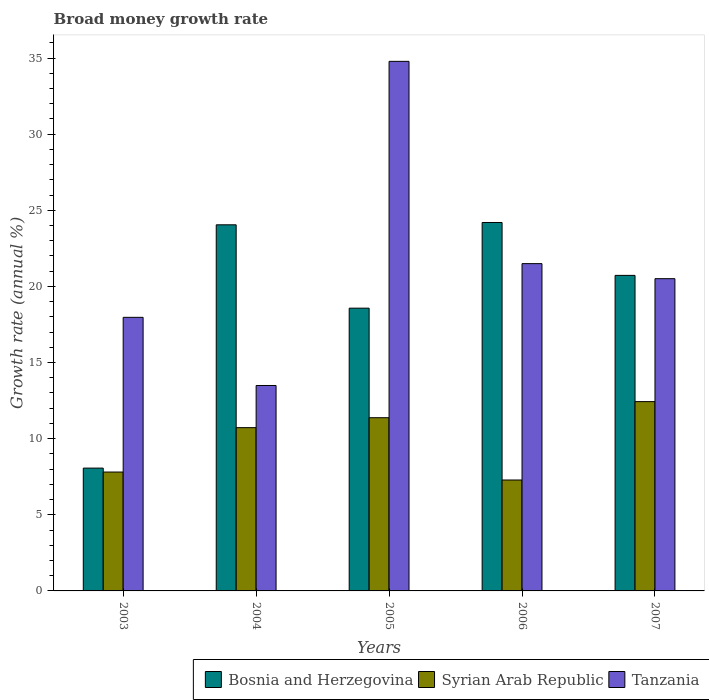How many different coloured bars are there?
Your answer should be compact. 3. How many groups of bars are there?
Your answer should be compact. 5. Are the number of bars per tick equal to the number of legend labels?
Provide a succinct answer. Yes. Are the number of bars on each tick of the X-axis equal?
Provide a short and direct response. Yes. How many bars are there on the 1st tick from the left?
Your answer should be compact. 3. How many bars are there on the 2nd tick from the right?
Your answer should be compact. 3. In how many cases, is the number of bars for a given year not equal to the number of legend labels?
Provide a succinct answer. 0. What is the growth rate in Bosnia and Herzegovina in 2007?
Make the answer very short. 20.72. Across all years, what is the maximum growth rate in Tanzania?
Your response must be concise. 34.78. Across all years, what is the minimum growth rate in Syrian Arab Republic?
Your answer should be compact. 7.29. In which year was the growth rate in Tanzania maximum?
Offer a very short reply. 2005. In which year was the growth rate in Syrian Arab Republic minimum?
Ensure brevity in your answer.  2006. What is the total growth rate in Bosnia and Herzegovina in the graph?
Your answer should be compact. 95.61. What is the difference between the growth rate in Bosnia and Herzegovina in 2003 and that in 2006?
Make the answer very short. -16.13. What is the difference between the growth rate in Syrian Arab Republic in 2005 and the growth rate in Bosnia and Herzegovina in 2004?
Ensure brevity in your answer.  -12.67. What is the average growth rate in Bosnia and Herzegovina per year?
Your answer should be very brief. 19.12. In the year 2006, what is the difference between the growth rate in Bosnia and Herzegovina and growth rate in Syrian Arab Republic?
Keep it short and to the point. 16.91. In how many years, is the growth rate in Tanzania greater than 20 %?
Make the answer very short. 3. What is the ratio of the growth rate in Syrian Arab Republic in 2004 to that in 2005?
Offer a terse response. 0.94. Is the growth rate in Bosnia and Herzegovina in 2003 less than that in 2004?
Keep it short and to the point. Yes. Is the difference between the growth rate in Bosnia and Herzegovina in 2005 and 2006 greater than the difference between the growth rate in Syrian Arab Republic in 2005 and 2006?
Ensure brevity in your answer.  No. What is the difference between the highest and the second highest growth rate in Syrian Arab Republic?
Keep it short and to the point. 1.06. What is the difference between the highest and the lowest growth rate in Tanzania?
Keep it short and to the point. 21.29. Is the sum of the growth rate in Bosnia and Herzegovina in 2005 and 2007 greater than the maximum growth rate in Tanzania across all years?
Offer a very short reply. Yes. What does the 3rd bar from the left in 2007 represents?
Your answer should be very brief. Tanzania. What does the 2nd bar from the right in 2004 represents?
Give a very brief answer. Syrian Arab Republic. Is it the case that in every year, the sum of the growth rate in Tanzania and growth rate in Syrian Arab Republic is greater than the growth rate in Bosnia and Herzegovina?
Provide a short and direct response. Yes. Are all the bars in the graph horizontal?
Your answer should be compact. No. What is the difference between two consecutive major ticks on the Y-axis?
Offer a terse response. 5. Does the graph contain any zero values?
Your answer should be very brief. No. Where does the legend appear in the graph?
Offer a terse response. Bottom right. What is the title of the graph?
Make the answer very short. Broad money growth rate. What is the label or title of the X-axis?
Your answer should be very brief. Years. What is the label or title of the Y-axis?
Provide a short and direct response. Growth rate (annual %). What is the Growth rate (annual %) in Bosnia and Herzegovina in 2003?
Your answer should be very brief. 8.07. What is the Growth rate (annual %) in Syrian Arab Republic in 2003?
Your answer should be compact. 7.81. What is the Growth rate (annual %) in Tanzania in 2003?
Your answer should be very brief. 17.97. What is the Growth rate (annual %) in Bosnia and Herzegovina in 2004?
Your answer should be compact. 24.05. What is the Growth rate (annual %) of Syrian Arab Republic in 2004?
Offer a terse response. 10.72. What is the Growth rate (annual %) of Tanzania in 2004?
Your answer should be very brief. 13.49. What is the Growth rate (annual %) of Bosnia and Herzegovina in 2005?
Offer a very short reply. 18.57. What is the Growth rate (annual %) of Syrian Arab Republic in 2005?
Your response must be concise. 11.38. What is the Growth rate (annual %) in Tanzania in 2005?
Provide a succinct answer. 34.78. What is the Growth rate (annual %) of Bosnia and Herzegovina in 2006?
Make the answer very short. 24.2. What is the Growth rate (annual %) in Syrian Arab Republic in 2006?
Ensure brevity in your answer.  7.29. What is the Growth rate (annual %) of Tanzania in 2006?
Your response must be concise. 21.5. What is the Growth rate (annual %) in Bosnia and Herzegovina in 2007?
Keep it short and to the point. 20.72. What is the Growth rate (annual %) in Syrian Arab Republic in 2007?
Your answer should be very brief. 12.43. What is the Growth rate (annual %) of Tanzania in 2007?
Offer a very short reply. 20.51. Across all years, what is the maximum Growth rate (annual %) in Bosnia and Herzegovina?
Offer a terse response. 24.2. Across all years, what is the maximum Growth rate (annual %) of Syrian Arab Republic?
Keep it short and to the point. 12.43. Across all years, what is the maximum Growth rate (annual %) in Tanzania?
Offer a very short reply. 34.78. Across all years, what is the minimum Growth rate (annual %) of Bosnia and Herzegovina?
Offer a terse response. 8.07. Across all years, what is the minimum Growth rate (annual %) in Syrian Arab Republic?
Your answer should be very brief. 7.29. Across all years, what is the minimum Growth rate (annual %) of Tanzania?
Offer a very short reply. 13.49. What is the total Growth rate (annual %) of Bosnia and Herzegovina in the graph?
Provide a short and direct response. 95.61. What is the total Growth rate (annual %) of Syrian Arab Republic in the graph?
Give a very brief answer. 49.63. What is the total Growth rate (annual %) of Tanzania in the graph?
Offer a very short reply. 108.25. What is the difference between the Growth rate (annual %) in Bosnia and Herzegovina in 2003 and that in 2004?
Your answer should be compact. -15.98. What is the difference between the Growth rate (annual %) in Syrian Arab Republic in 2003 and that in 2004?
Offer a terse response. -2.91. What is the difference between the Growth rate (annual %) in Tanzania in 2003 and that in 2004?
Provide a short and direct response. 4.48. What is the difference between the Growth rate (annual %) in Bosnia and Herzegovina in 2003 and that in 2005?
Your answer should be compact. -10.5. What is the difference between the Growth rate (annual %) of Syrian Arab Republic in 2003 and that in 2005?
Make the answer very short. -3.57. What is the difference between the Growth rate (annual %) of Tanzania in 2003 and that in 2005?
Your answer should be compact. -16.81. What is the difference between the Growth rate (annual %) of Bosnia and Herzegovina in 2003 and that in 2006?
Ensure brevity in your answer.  -16.13. What is the difference between the Growth rate (annual %) of Syrian Arab Republic in 2003 and that in 2006?
Your answer should be compact. 0.52. What is the difference between the Growth rate (annual %) of Tanzania in 2003 and that in 2006?
Make the answer very short. -3.53. What is the difference between the Growth rate (annual %) in Bosnia and Herzegovina in 2003 and that in 2007?
Offer a terse response. -12.66. What is the difference between the Growth rate (annual %) in Syrian Arab Republic in 2003 and that in 2007?
Your answer should be very brief. -4.62. What is the difference between the Growth rate (annual %) of Tanzania in 2003 and that in 2007?
Your answer should be very brief. -2.54. What is the difference between the Growth rate (annual %) in Bosnia and Herzegovina in 2004 and that in 2005?
Offer a very short reply. 5.48. What is the difference between the Growth rate (annual %) in Syrian Arab Republic in 2004 and that in 2005?
Your answer should be very brief. -0.65. What is the difference between the Growth rate (annual %) of Tanzania in 2004 and that in 2005?
Provide a short and direct response. -21.29. What is the difference between the Growth rate (annual %) in Bosnia and Herzegovina in 2004 and that in 2006?
Keep it short and to the point. -0.15. What is the difference between the Growth rate (annual %) in Syrian Arab Republic in 2004 and that in 2006?
Your answer should be very brief. 3.44. What is the difference between the Growth rate (annual %) of Tanzania in 2004 and that in 2006?
Offer a very short reply. -8. What is the difference between the Growth rate (annual %) in Bosnia and Herzegovina in 2004 and that in 2007?
Provide a succinct answer. 3.32. What is the difference between the Growth rate (annual %) in Syrian Arab Republic in 2004 and that in 2007?
Keep it short and to the point. -1.71. What is the difference between the Growth rate (annual %) of Tanzania in 2004 and that in 2007?
Provide a succinct answer. -7.02. What is the difference between the Growth rate (annual %) of Bosnia and Herzegovina in 2005 and that in 2006?
Provide a short and direct response. -5.63. What is the difference between the Growth rate (annual %) of Syrian Arab Republic in 2005 and that in 2006?
Make the answer very short. 4.09. What is the difference between the Growth rate (annual %) in Tanzania in 2005 and that in 2006?
Offer a terse response. 13.29. What is the difference between the Growth rate (annual %) of Bosnia and Herzegovina in 2005 and that in 2007?
Your answer should be compact. -2.15. What is the difference between the Growth rate (annual %) in Syrian Arab Republic in 2005 and that in 2007?
Ensure brevity in your answer.  -1.06. What is the difference between the Growth rate (annual %) of Tanzania in 2005 and that in 2007?
Offer a very short reply. 14.27. What is the difference between the Growth rate (annual %) in Bosnia and Herzegovina in 2006 and that in 2007?
Ensure brevity in your answer.  3.47. What is the difference between the Growth rate (annual %) in Syrian Arab Republic in 2006 and that in 2007?
Offer a very short reply. -5.15. What is the difference between the Growth rate (annual %) of Bosnia and Herzegovina in 2003 and the Growth rate (annual %) of Syrian Arab Republic in 2004?
Keep it short and to the point. -2.66. What is the difference between the Growth rate (annual %) of Bosnia and Herzegovina in 2003 and the Growth rate (annual %) of Tanzania in 2004?
Offer a terse response. -5.43. What is the difference between the Growth rate (annual %) of Syrian Arab Republic in 2003 and the Growth rate (annual %) of Tanzania in 2004?
Your response must be concise. -5.68. What is the difference between the Growth rate (annual %) of Bosnia and Herzegovina in 2003 and the Growth rate (annual %) of Syrian Arab Republic in 2005?
Provide a succinct answer. -3.31. What is the difference between the Growth rate (annual %) of Bosnia and Herzegovina in 2003 and the Growth rate (annual %) of Tanzania in 2005?
Offer a very short reply. -26.72. What is the difference between the Growth rate (annual %) in Syrian Arab Republic in 2003 and the Growth rate (annual %) in Tanzania in 2005?
Offer a very short reply. -26.97. What is the difference between the Growth rate (annual %) of Bosnia and Herzegovina in 2003 and the Growth rate (annual %) of Syrian Arab Republic in 2006?
Keep it short and to the point. 0.78. What is the difference between the Growth rate (annual %) in Bosnia and Herzegovina in 2003 and the Growth rate (annual %) in Tanzania in 2006?
Offer a very short reply. -13.43. What is the difference between the Growth rate (annual %) in Syrian Arab Republic in 2003 and the Growth rate (annual %) in Tanzania in 2006?
Provide a short and direct response. -13.69. What is the difference between the Growth rate (annual %) of Bosnia and Herzegovina in 2003 and the Growth rate (annual %) of Syrian Arab Republic in 2007?
Make the answer very short. -4.37. What is the difference between the Growth rate (annual %) of Bosnia and Herzegovina in 2003 and the Growth rate (annual %) of Tanzania in 2007?
Give a very brief answer. -12.44. What is the difference between the Growth rate (annual %) of Syrian Arab Republic in 2003 and the Growth rate (annual %) of Tanzania in 2007?
Make the answer very short. -12.7. What is the difference between the Growth rate (annual %) in Bosnia and Herzegovina in 2004 and the Growth rate (annual %) in Syrian Arab Republic in 2005?
Provide a short and direct response. 12.67. What is the difference between the Growth rate (annual %) of Bosnia and Herzegovina in 2004 and the Growth rate (annual %) of Tanzania in 2005?
Provide a succinct answer. -10.74. What is the difference between the Growth rate (annual %) of Syrian Arab Republic in 2004 and the Growth rate (annual %) of Tanzania in 2005?
Offer a terse response. -24.06. What is the difference between the Growth rate (annual %) in Bosnia and Herzegovina in 2004 and the Growth rate (annual %) in Syrian Arab Republic in 2006?
Keep it short and to the point. 16.76. What is the difference between the Growth rate (annual %) in Bosnia and Herzegovina in 2004 and the Growth rate (annual %) in Tanzania in 2006?
Your answer should be compact. 2.55. What is the difference between the Growth rate (annual %) in Syrian Arab Republic in 2004 and the Growth rate (annual %) in Tanzania in 2006?
Offer a very short reply. -10.77. What is the difference between the Growth rate (annual %) of Bosnia and Herzegovina in 2004 and the Growth rate (annual %) of Syrian Arab Republic in 2007?
Your answer should be compact. 11.61. What is the difference between the Growth rate (annual %) in Bosnia and Herzegovina in 2004 and the Growth rate (annual %) in Tanzania in 2007?
Your answer should be very brief. 3.54. What is the difference between the Growth rate (annual %) in Syrian Arab Republic in 2004 and the Growth rate (annual %) in Tanzania in 2007?
Your answer should be very brief. -9.78. What is the difference between the Growth rate (annual %) in Bosnia and Herzegovina in 2005 and the Growth rate (annual %) in Syrian Arab Republic in 2006?
Keep it short and to the point. 11.29. What is the difference between the Growth rate (annual %) in Bosnia and Herzegovina in 2005 and the Growth rate (annual %) in Tanzania in 2006?
Offer a very short reply. -2.92. What is the difference between the Growth rate (annual %) of Syrian Arab Republic in 2005 and the Growth rate (annual %) of Tanzania in 2006?
Provide a succinct answer. -10.12. What is the difference between the Growth rate (annual %) of Bosnia and Herzegovina in 2005 and the Growth rate (annual %) of Syrian Arab Republic in 2007?
Your response must be concise. 6.14. What is the difference between the Growth rate (annual %) in Bosnia and Herzegovina in 2005 and the Growth rate (annual %) in Tanzania in 2007?
Your answer should be very brief. -1.94. What is the difference between the Growth rate (annual %) in Syrian Arab Republic in 2005 and the Growth rate (annual %) in Tanzania in 2007?
Offer a terse response. -9.13. What is the difference between the Growth rate (annual %) of Bosnia and Herzegovina in 2006 and the Growth rate (annual %) of Syrian Arab Republic in 2007?
Offer a very short reply. 11.76. What is the difference between the Growth rate (annual %) of Bosnia and Herzegovina in 2006 and the Growth rate (annual %) of Tanzania in 2007?
Provide a succinct answer. 3.69. What is the difference between the Growth rate (annual %) of Syrian Arab Republic in 2006 and the Growth rate (annual %) of Tanzania in 2007?
Offer a very short reply. -13.22. What is the average Growth rate (annual %) of Bosnia and Herzegovina per year?
Make the answer very short. 19.12. What is the average Growth rate (annual %) of Syrian Arab Republic per year?
Offer a very short reply. 9.93. What is the average Growth rate (annual %) in Tanzania per year?
Your answer should be very brief. 21.65. In the year 2003, what is the difference between the Growth rate (annual %) of Bosnia and Herzegovina and Growth rate (annual %) of Syrian Arab Republic?
Give a very brief answer. 0.26. In the year 2003, what is the difference between the Growth rate (annual %) in Bosnia and Herzegovina and Growth rate (annual %) in Tanzania?
Give a very brief answer. -9.9. In the year 2003, what is the difference between the Growth rate (annual %) in Syrian Arab Republic and Growth rate (annual %) in Tanzania?
Make the answer very short. -10.16. In the year 2004, what is the difference between the Growth rate (annual %) in Bosnia and Herzegovina and Growth rate (annual %) in Syrian Arab Republic?
Your response must be concise. 13.32. In the year 2004, what is the difference between the Growth rate (annual %) in Bosnia and Herzegovina and Growth rate (annual %) in Tanzania?
Offer a very short reply. 10.55. In the year 2004, what is the difference between the Growth rate (annual %) of Syrian Arab Republic and Growth rate (annual %) of Tanzania?
Offer a terse response. -2.77. In the year 2005, what is the difference between the Growth rate (annual %) of Bosnia and Herzegovina and Growth rate (annual %) of Syrian Arab Republic?
Make the answer very short. 7.19. In the year 2005, what is the difference between the Growth rate (annual %) of Bosnia and Herzegovina and Growth rate (annual %) of Tanzania?
Make the answer very short. -16.21. In the year 2005, what is the difference between the Growth rate (annual %) of Syrian Arab Republic and Growth rate (annual %) of Tanzania?
Your answer should be very brief. -23.41. In the year 2006, what is the difference between the Growth rate (annual %) in Bosnia and Herzegovina and Growth rate (annual %) in Syrian Arab Republic?
Provide a short and direct response. 16.91. In the year 2006, what is the difference between the Growth rate (annual %) of Bosnia and Herzegovina and Growth rate (annual %) of Tanzania?
Provide a short and direct response. 2.7. In the year 2006, what is the difference between the Growth rate (annual %) in Syrian Arab Republic and Growth rate (annual %) in Tanzania?
Provide a succinct answer. -14.21. In the year 2007, what is the difference between the Growth rate (annual %) in Bosnia and Herzegovina and Growth rate (annual %) in Syrian Arab Republic?
Your response must be concise. 8.29. In the year 2007, what is the difference between the Growth rate (annual %) in Bosnia and Herzegovina and Growth rate (annual %) in Tanzania?
Your answer should be compact. 0.22. In the year 2007, what is the difference between the Growth rate (annual %) of Syrian Arab Republic and Growth rate (annual %) of Tanzania?
Offer a very short reply. -8.07. What is the ratio of the Growth rate (annual %) of Bosnia and Herzegovina in 2003 to that in 2004?
Your response must be concise. 0.34. What is the ratio of the Growth rate (annual %) of Syrian Arab Republic in 2003 to that in 2004?
Your answer should be compact. 0.73. What is the ratio of the Growth rate (annual %) of Tanzania in 2003 to that in 2004?
Keep it short and to the point. 1.33. What is the ratio of the Growth rate (annual %) in Bosnia and Herzegovina in 2003 to that in 2005?
Ensure brevity in your answer.  0.43. What is the ratio of the Growth rate (annual %) of Syrian Arab Republic in 2003 to that in 2005?
Ensure brevity in your answer.  0.69. What is the ratio of the Growth rate (annual %) of Tanzania in 2003 to that in 2005?
Provide a short and direct response. 0.52. What is the ratio of the Growth rate (annual %) in Bosnia and Herzegovina in 2003 to that in 2006?
Offer a terse response. 0.33. What is the ratio of the Growth rate (annual %) in Syrian Arab Republic in 2003 to that in 2006?
Your answer should be compact. 1.07. What is the ratio of the Growth rate (annual %) in Tanzania in 2003 to that in 2006?
Give a very brief answer. 0.84. What is the ratio of the Growth rate (annual %) of Bosnia and Herzegovina in 2003 to that in 2007?
Your answer should be compact. 0.39. What is the ratio of the Growth rate (annual %) of Syrian Arab Republic in 2003 to that in 2007?
Ensure brevity in your answer.  0.63. What is the ratio of the Growth rate (annual %) in Tanzania in 2003 to that in 2007?
Make the answer very short. 0.88. What is the ratio of the Growth rate (annual %) in Bosnia and Herzegovina in 2004 to that in 2005?
Make the answer very short. 1.29. What is the ratio of the Growth rate (annual %) in Syrian Arab Republic in 2004 to that in 2005?
Keep it short and to the point. 0.94. What is the ratio of the Growth rate (annual %) in Tanzania in 2004 to that in 2005?
Offer a terse response. 0.39. What is the ratio of the Growth rate (annual %) of Bosnia and Herzegovina in 2004 to that in 2006?
Make the answer very short. 0.99. What is the ratio of the Growth rate (annual %) in Syrian Arab Republic in 2004 to that in 2006?
Ensure brevity in your answer.  1.47. What is the ratio of the Growth rate (annual %) in Tanzania in 2004 to that in 2006?
Your answer should be very brief. 0.63. What is the ratio of the Growth rate (annual %) of Bosnia and Herzegovina in 2004 to that in 2007?
Give a very brief answer. 1.16. What is the ratio of the Growth rate (annual %) in Syrian Arab Republic in 2004 to that in 2007?
Offer a very short reply. 0.86. What is the ratio of the Growth rate (annual %) in Tanzania in 2004 to that in 2007?
Your answer should be very brief. 0.66. What is the ratio of the Growth rate (annual %) in Bosnia and Herzegovina in 2005 to that in 2006?
Offer a terse response. 0.77. What is the ratio of the Growth rate (annual %) of Syrian Arab Republic in 2005 to that in 2006?
Your response must be concise. 1.56. What is the ratio of the Growth rate (annual %) of Tanzania in 2005 to that in 2006?
Offer a terse response. 1.62. What is the ratio of the Growth rate (annual %) in Bosnia and Herzegovina in 2005 to that in 2007?
Your answer should be very brief. 0.9. What is the ratio of the Growth rate (annual %) of Syrian Arab Republic in 2005 to that in 2007?
Your response must be concise. 0.92. What is the ratio of the Growth rate (annual %) in Tanzania in 2005 to that in 2007?
Your answer should be very brief. 1.7. What is the ratio of the Growth rate (annual %) of Bosnia and Herzegovina in 2006 to that in 2007?
Make the answer very short. 1.17. What is the ratio of the Growth rate (annual %) of Syrian Arab Republic in 2006 to that in 2007?
Offer a terse response. 0.59. What is the ratio of the Growth rate (annual %) of Tanzania in 2006 to that in 2007?
Ensure brevity in your answer.  1.05. What is the difference between the highest and the second highest Growth rate (annual %) of Bosnia and Herzegovina?
Ensure brevity in your answer.  0.15. What is the difference between the highest and the second highest Growth rate (annual %) in Syrian Arab Republic?
Offer a terse response. 1.06. What is the difference between the highest and the second highest Growth rate (annual %) of Tanzania?
Keep it short and to the point. 13.29. What is the difference between the highest and the lowest Growth rate (annual %) in Bosnia and Herzegovina?
Provide a short and direct response. 16.13. What is the difference between the highest and the lowest Growth rate (annual %) in Syrian Arab Republic?
Provide a short and direct response. 5.15. What is the difference between the highest and the lowest Growth rate (annual %) of Tanzania?
Give a very brief answer. 21.29. 